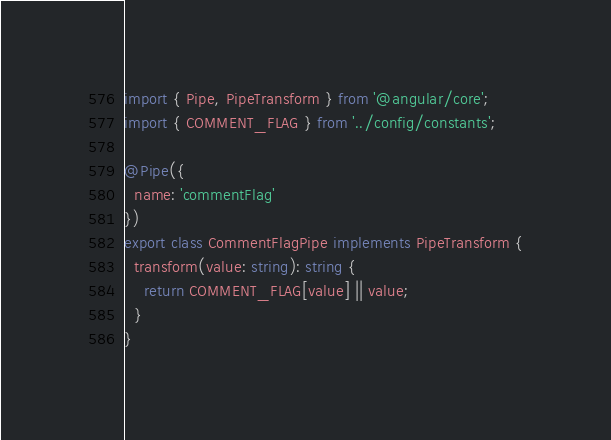Convert code to text. <code><loc_0><loc_0><loc_500><loc_500><_TypeScript_>import { Pipe, PipeTransform } from '@angular/core';
import { COMMENT_FLAG } from '../config/constants';

@Pipe({
  name: 'commentFlag'
})
export class CommentFlagPipe implements PipeTransform {
  transform(value: string): string {
    return COMMENT_FLAG[value] || value;
  }
}
</code> 